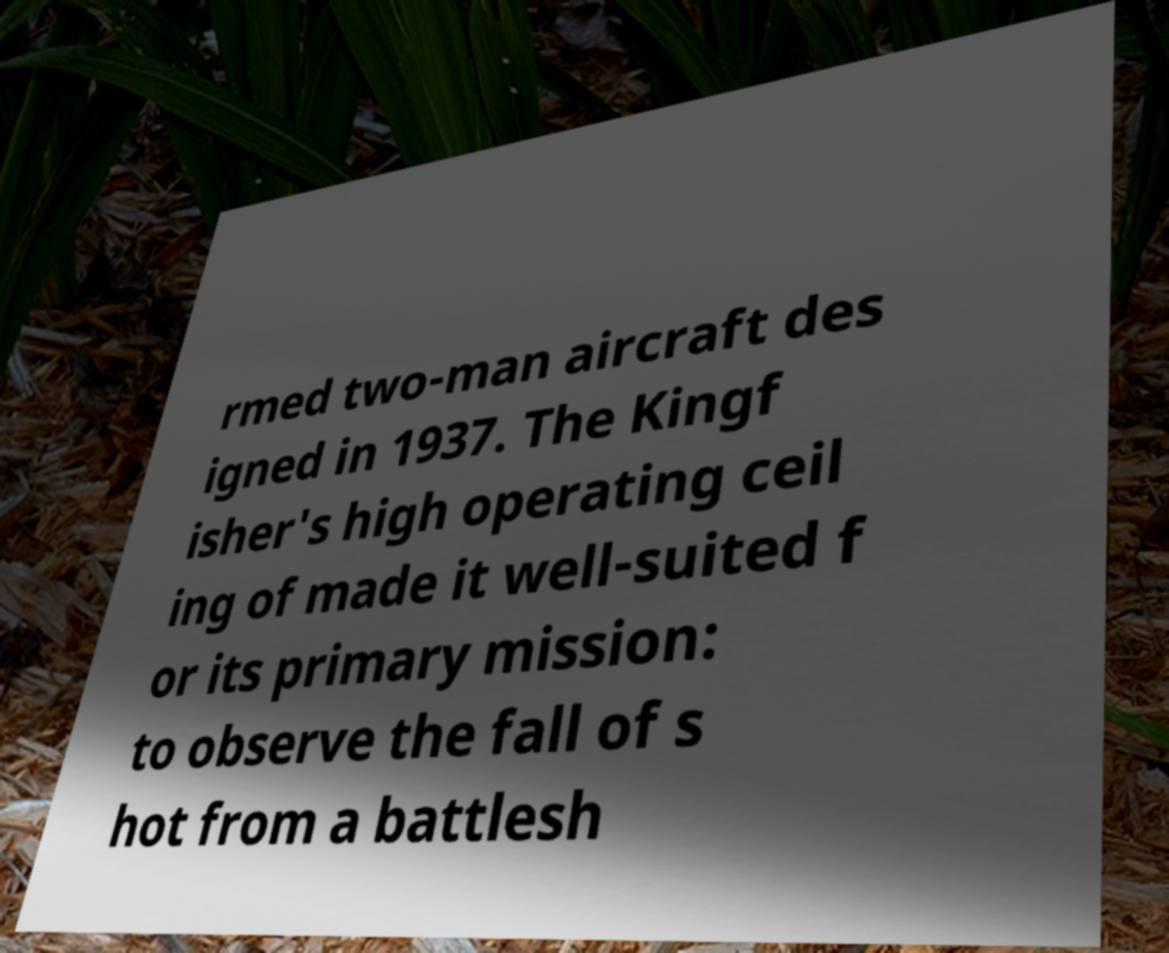Please identify and transcribe the text found in this image. rmed two-man aircraft des igned in 1937. The Kingf isher's high operating ceil ing of made it well-suited f or its primary mission: to observe the fall of s hot from a battlesh 